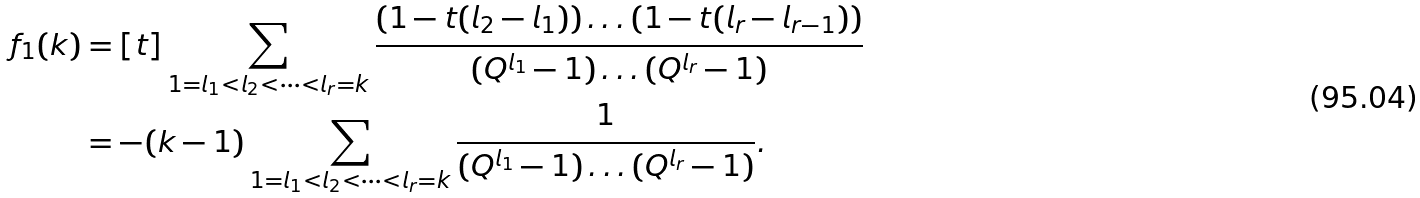<formula> <loc_0><loc_0><loc_500><loc_500>f _ { 1 } ( k ) & = [ t ] \sum _ { 1 = l _ { 1 } < l _ { 2 } < \dots < l _ { r } = k } \frac { \left ( 1 - t ( l _ { 2 } - l _ { 1 } ) \right ) \dots \left ( 1 - t ( l _ { r } - l _ { r - 1 } ) \right ) } { ( Q ^ { l _ { 1 } } - 1 ) \dots ( Q ^ { l _ { r } } - 1 ) } \\ & = - ( k - 1 ) \sum _ { 1 = l _ { 1 } < l _ { 2 } < \dots < l _ { r } = k } \frac { 1 } { ( Q ^ { l _ { 1 } } - 1 ) \dots ( Q ^ { l _ { r } } - 1 ) } .</formula> 